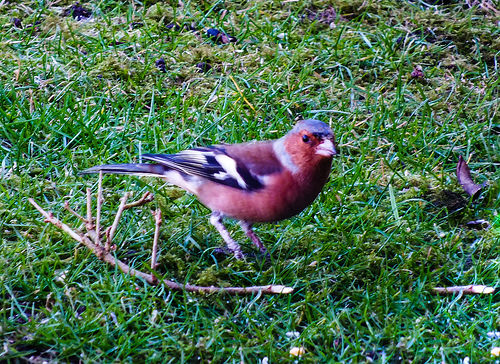<image>
Can you confirm if the stick is under the bird? Yes. The stick is positioned underneath the bird, with the bird above it in the vertical space. 